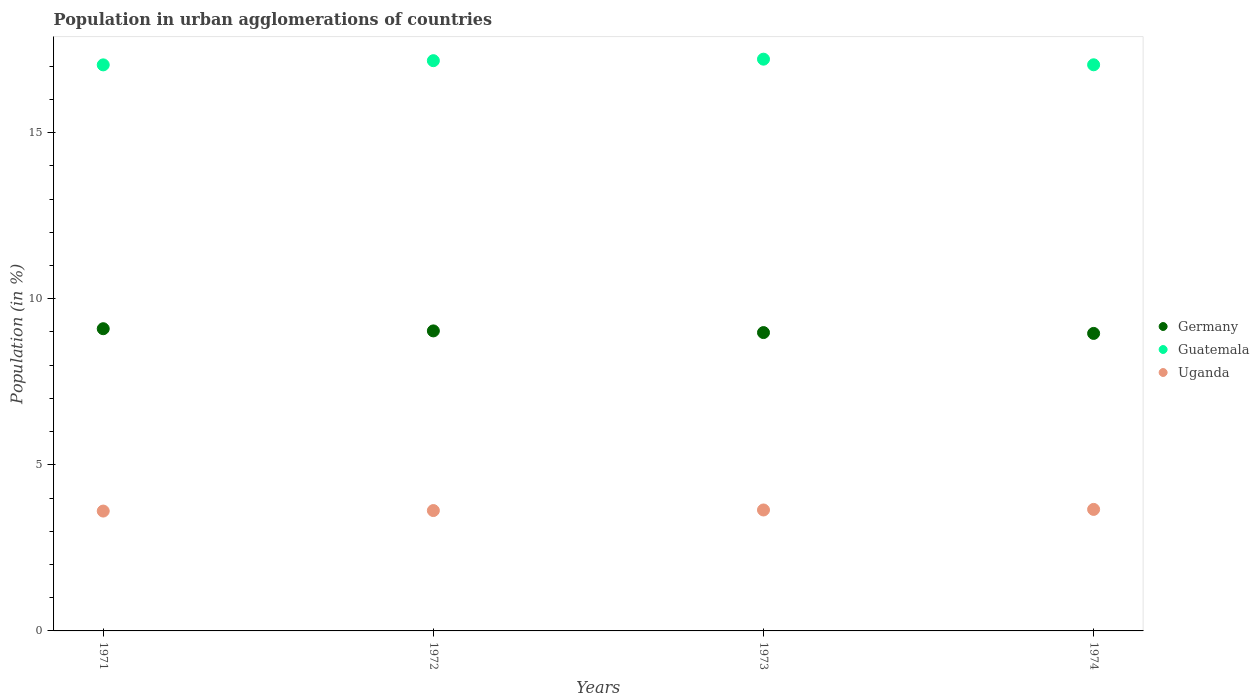How many different coloured dotlines are there?
Ensure brevity in your answer.  3. Is the number of dotlines equal to the number of legend labels?
Provide a succinct answer. Yes. What is the percentage of population in urban agglomerations in Germany in 1973?
Offer a terse response. 8.98. Across all years, what is the maximum percentage of population in urban agglomerations in Guatemala?
Provide a succinct answer. 17.21. Across all years, what is the minimum percentage of population in urban agglomerations in Germany?
Your answer should be very brief. 8.96. In which year was the percentage of population in urban agglomerations in Germany minimum?
Your answer should be very brief. 1974. What is the total percentage of population in urban agglomerations in Uganda in the graph?
Your response must be concise. 14.53. What is the difference between the percentage of population in urban agglomerations in Guatemala in 1971 and that in 1972?
Your answer should be very brief. -0.13. What is the difference between the percentage of population in urban agglomerations in Uganda in 1973 and the percentage of population in urban agglomerations in Germany in 1974?
Offer a terse response. -5.31. What is the average percentage of population in urban agglomerations in Germany per year?
Keep it short and to the point. 9.02. In the year 1971, what is the difference between the percentage of population in urban agglomerations in Uganda and percentage of population in urban agglomerations in Germany?
Your answer should be very brief. -5.49. In how many years, is the percentage of population in urban agglomerations in Germany greater than 15 %?
Offer a terse response. 0. What is the ratio of the percentage of population in urban agglomerations in Uganda in 1972 to that in 1974?
Your answer should be very brief. 0.99. Is the difference between the percentage of population in urban agglomerations in Uganda in 1972 and 1973 greater than the difference between the percentage of population in urban agglomerations in Germany in 1972 and 1973?
Offer a very short reply. No. What is the difference between the highest and the second highest percentage of population in urban agglomerations in Uganda?
Give a very brief answer. 0.02. What is the difference between the highest and the lowest percentage of population in urban agglomerations in Guatemala?
Keep it short and to the point. 0.17. In how many years, is the percentage of population in urban agglomerations in Germany greater than the average percentage of population in urban agglomerations in Germany taken over all years?
Give a very brief answer. 2. Is it the case that in every year, the sum of the percentage of population in urban agglomerations in Germany and percentage of population in urban agglomerations in Guatemala  is greater than the percentage of population in urban agglomerations in Uganda?
Provide a succinct answer. Yes. Is the percentage of population in urban agglomerations in Guatemala strictly less than the percentage of population in urban agglomerations in Uganda over the years?
Ensure brevity in your answer.  No. How many dotlines are there?
Offer a terse response. 3. How many years are there in the graph?
Provide a short and direct response. 4. Does the graph contain grids?
Provide a short and direct response. No. How many legend labels are there?
Ensure brevity in your answer.  3. What is the title of the graph?
Provide a short and direct response. Population in urban agglomerations of countries. Does "Zimbabwe" appear as one of the legend labels in the graph?
Offer a terse response. No. What is the Population (in %) of Germany in 1971?
Offer a very short reply. 9.1. What is the Population (in %) of Guatemala in 1971?
Your answer should be compact. 17.04. What is the Population (in %) of Uganda in 1971?
Your response must be concise. 3.61. What is the Population (in %) in Germany in 1972?
Provide a succinct answer. 9.03. What is the Population (in %) of Guatemala in 1972?
Your answer should be compact. 17.16. What is the Population (in %) in Uganda in 1972?
Make the answer very short. 3.62. What is the Population (in %) in Germany in 1973?
Provide a succinct answer. 8.98. What is the Population (in %) in Guatemala in 1973?
Offer a terse response. 17.21. What is the Population (in %) in Uganda in 1973?
Give a very brief answer. 3.64. What is the Population (in %) of Germany in 1974?
Ensure brevity in your answer.  8.96. What is the Population (in %) in Guatemala in 1974?
Offer a terse response. 17.04. What is the Population (in %) in Uganda in 1974?
Your response must be concise. 3.66. Across all years, what is the maximum Population (in %) of Germany?
Make the answer very short. 9.1. Across all years, what is the maximum Population (in %) of Guatemala?
Ensure brevity in your answer.  17.21. Across all years, what is the maximum Population (in %) in Uganda?
Offer a very short reply. 3.66. Across all years, what is the minimum Population (in %) in Germany?
Give a very brief answer. 8.96. Across all years, what is the minimum Population (in %) in Guatemala?
Provide a short and direct response. 17.04. Across all years, what is the minimum Population (in %) of Uganda?
Provide a short and direct response. 3.61. What is the total Population (in %) in Germany in the graph?
Provide a short and direct response. 36.06. What is the total Population (in %) of Guatemala in the graph?
Make the answer very short. 68.45. What is the total Population (in %) of Uganda in the graph?
Offer a very short reply. 14.53. What is the difference between the Population (in %) of Germany in 1971 and that in 1972?
Offer a very short reply. 0.07. What is the difference between the Population (in %) in Guatemala in 1971 and that in 1972?
Keep it short and to the point. -0.13. What is the difference between the Population (in %) of Uganda in 1971 and that in 1972?
Your response must be concise. -0.02. What is the difference between the Population (in %) in Germany in 1971 and that in 1973?
Your answer should be compact. 0.12. What is the difference between the Population (in %) of Guatemala in 1971 and that in 1973?
Make the answer very short. -0.17. What is the difference between the Population (in %) in Uganda in 1971 and that in 1973?
Provide a succinct answer. -0.03. What is the difference between the Population (in %) in Germany in 1971 and that in 1974?
Make the answer very short. 0.14. What is the difference between the Population (in %) of Guatemala in 1971 and that in 1974?
Make the answer very short. -0. What is the difference between the Population (in %) in Uganda in 1971 and that in 1974?
Offer a terse response. -0.05. What is the difference between the Population (in %) in Germany in 1972 and that in 1973?
Provide a short and direct response. 0.05. What is the difference between the Population (in %) in Guatemala in 1972 and that in 1973?
Offer a very short reply. -0.05. What is the difference between the Population (in %) of Uganda in 1972 and that in 1973?
Give a very brief answer. -0.02. What is the difference between the Population (in %) of Germany in 1972 and that in 1974?
Keep it short and to the point. 0.08. What is the difference between the Population (in %) in Guatemala in 1972 and that in 1974?
Keep it short and to the point. 0.12. What is the difference between the Population (in %) of Uganda in 1972 and that in 1974?
Offer a terse response. -0.03. What is the difference between the Population (in %) of Germany in 1973 and that in 1974?
Provide a short and direct response. 0.03. What is the difference between the Population (in %) in Guatemala in 1973 and that in 1974?
Make the answer very short. 0.17. What is the difference between the Population (in %) in Uganda in 1973 and that in 1974?
Keep it short and to the point. -0.02. What is the difference between the Population (in %) in Germany in 1971 and the Population (in %) in Guatemala in 1972?
Your response must be concise. -8.07. What is the difference between the Population (in %) of Germany in 1971 and the Population (in %) of Uganda in 1972?
Your response must be concise. 5.47. What is the difference between the Population (in %) of Guatemala in 1971 and the Population (in %) of Uganda in 1972?
Make the answer very short. 13.42. What is the difference between the Population (in %) in Germany in 1971 and the Population (in %) in Guatemala in 1973?
Your response must be concise. -8.11. What is the difference between the Population (in %) of Germany in 1971 and the Population (in %) of Uganda in 1973?
Provide a short and direct response. 5.46. What is the difference between the Population (in %) in Guatemala in 1971 and the Population (in %) in Uganda in 1973?
Keep it short and to the point. 13.4. What is the difference between the Population (in %) in Germany in 1971 and the Population (in %) in Guatemala in 1974?
Ensure brevity in your answer.  -7.94. What is the difference between the Population (in %) of Germany in 1971 and the Population (in %) of Uganda in 1974?
Offer a very short reply. 5.44. What is the difference between the Population (in %) in Guatemala in 1971 and the Population (in %) in Uganda in 1974?
Make the answer very short. 13.38. What is the difference between the Population (in %) of Germany in 1972 and the Population (in %) of Guatemala in 1973?
Make the answer very short. -8.18. What is the difference between the Population (in %) in Germany in 1972 and the Population (in %) in Uganda in 1973?
Your answer should be compact. 5.39. What is the difference between the Population (in %) in Guatemala in 1972 and the Population (in %) in Uganda in 1973?
Your answer should be very brief. 13.52. What is the difference between the Population (in %) in Germany in 1972 and the Population (in %) in Guatemala in 1974?
Make the answer very short. -8.01. What is the difference between the Population (in %) in Germany in 1972 and the Population (in %) in Uganda in 1974?
Offer a terse response. 5.37. What is the difference between the Population (in %) of Guatemala in 1972 and the Population (in %) of Uganda in 1974?
Make the answer very short. 13.51. What is the difference between the Population (in %) of Germany in 1973 and the Population (in %) of Guatemala in 1974?
Give a very brief answer. -8.06. What is the difference between the Population (in %) of Germany in 1973 and the Population (in %) of Uganda in 1974?
Your response must be concise. 5.32. What is the difference between the Population (in %) of Guatemala in 1973 and the Population (in %) of Uganda in 1974?
Your answer should be very brief. 13.55. What is the average Population (in %) in Germany per year?
Provide a short and direct response. 9.02. What is the average Population (in %) of Guatemala per year?
Your answer should be compact. 17.11. What is the average Population (in %) in Uganda per year?
Make the answer very short. 3.63. In the year 1971, what is the difference between the Population (in %) of Germany and Population (in %) of Guatemala?
Provide a short and direct response. -7.94. In the year 1971, what is the difference between the Population (in %) in Germany and Population (in %) in Uganda?
Make the answer very short. 5.49. In the year 1971, what is the difference between the Population (in %) of Guatemala and Population (in %) of Uganda?
Your answer should be compact. 13.43. In the year 1972, what is the difference between the Population (in %) in Germany and Population (in %) in Guatemala?
Offer a very short reply. -8.13. In the year 1972, what is the difference between the Population (in %) in Germany and Population (in %) in Uganda?
Your answer should be compact. 5.41. In the year 1972, what is the difference between the Population (in %) in Guatemala and Population (in %) in Uganda?
Your answer should be compact. 13.54. In the year 1973, what is the difference between the Population (in %) of Germany and Population (in %) of Guatemala?
Make the answer very short. -8.23. In the year 1973, what is the difference between the Population (in %) of Germany and Population (in %) of Uganda?
Provide a short and direct response. 5.34. In the year 1973, what is the difference between the Population (in %) in Guatemala and Population (in %) in Uganda?
Provide a short and direct response. 13.57. In the year 1974, what is the difference between the Population (in %) of Germany and Population (in %) of Guatemala?
Your response must be concise. -8.09. In the year 1974, what is the difference between the Population (in %) of Germany and Population (in %) of Uganda?
Give a very brief answer. 5.3. In the year 1974, what is the difference between the Population (in %) of Guatemala and Population (in %) of Uganda?
Give a very brief answer. 13.38. What is the ratio of the Population (in %) in Germany in 1971 to that in 1972?
Your response must be concise. 1.01. What is the ratio of the Population (in %) of Uganda in 1971 to that in 1972?
Ensure brevity in your answer.  1. What is the ratio of the Population (in %) in Germany in 1971 to that in 1973?
Give a very brief answer. 1.01. What is the ratio of the Population (in %) of Germany in 1971 to that in 1974?
Provide a short and direct response. 1.02. What is the ratio of the Population (in %) of Guatemala in 1971 to that in 1974?
Ensure brevity in your answer.  1. What is the ratio of the Population (in %) in Uganda in 1971 to that in 1974?
Your response must be concise. 0.99. What is the ratio of the Population (in %) in Germany in 1972 to that in 1973?
Give a very brief answer. 1.01. What is the ratio of the Population (in %) in Guatemala in 1972 to that in 1973?
Ensure brevity in your answer.  1. What is the ratio of the Population (in %) in Germany in 1972 to that in 1974?
Your answer should be very brief. 1.01. What is the ratio of the Population (in %) of Guatemala in 1972 to that in 1974?
Your answer should be compact. 1.01. What is the ratio of the Population (in %) in Guatemala in 1973 to that in 1974?
Offer a terse response. 1.01. What is the difference between the highest and the second highest Population (in %) of Germany?
Ensure brevity in your answer.  0.07. What is the difference between the highest and the second highest Population (in %) of Guatemala?
Give a very brief answer. 0.05. What is the difference between the highest and the second highest Population (in %) of Uganda?
Your answer should be compact. 0.02. What is the difference between the highest and the lowest Population (in %) of Germany?
Provide a succinct answer. 0.14. What is the difference between the highest and the lowest Population (in %) in Guatemala?
Ensure brevity in your answer.  0.17. What is the difference between the highest and the lowest Population (in %) of Uganda?
Your answer should be compact. 0.05. 